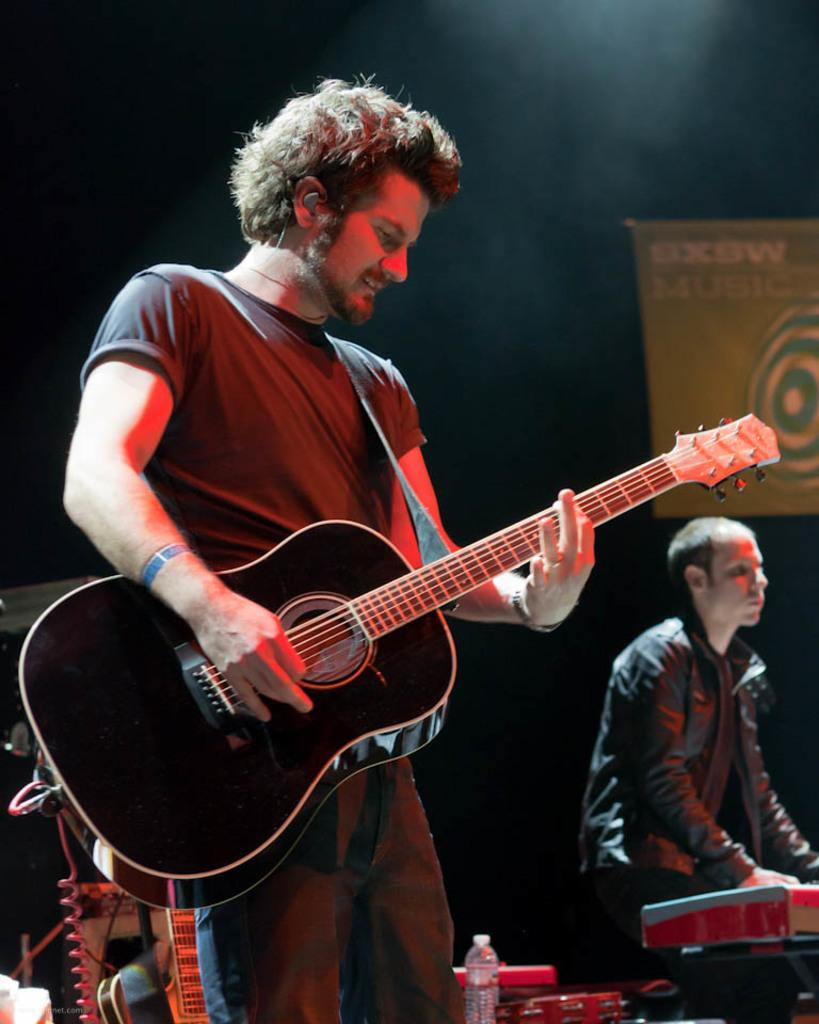How many people are in the image? There are two people in the image. What are the people doing in the image? Both people are standing and playing musical instruments. What type of volleyball is being played in the image? There is no volleyball present in the image; it features two people playing musical instruments. How much wealth is visible in the image? There is no reference to wealth in the image, as it focuses on two people playing musical instruments. 